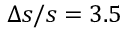Convert formula to latex. <formula><loc_0><loc_0><loc_500><loc_500>\Delta s / s = 3 . 5</formula> 